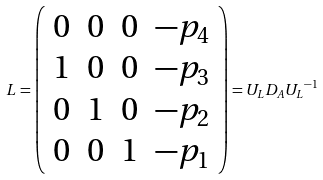Convert formula to latex. <formula><loc_0><loc_0><loc_500><loc_500>L = \left ( \begin{array} { c c c c } 0 & 0 & 0 & - p _ { 4 } \\ 1 & 0 & 0 & - p _ { 3 } \\ 0 & 1 & 0 & - p _ { 2 } \\ 0 & 0 & 1 & - p _ { 1 } \end{array} \right ) = U _ { L } D _ { A } { U _ { L } } ^ { - 1 }</formula> 